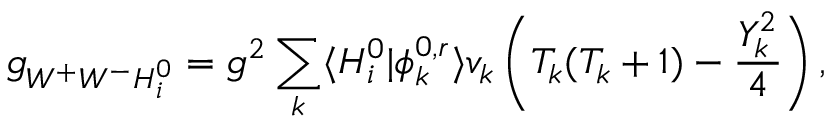Convert formula to latex. <formula><loc_0><loc_0><loc_500><loc_500>g _ { W ^ { + } W ^ { - } H _ { i } ^ { 0 } } = g ^ { 2 } \sum _ { k } \langle H _ { i } ^ { 0 } | \phi _ { k } ^ { 0 , r } \rangle v _ { k } \left ( T _ { k } ( T _ { k } + 1 ) - \frac { Y _ { k } ^ { 2 } } { 4 } \right ) ,</formula> 